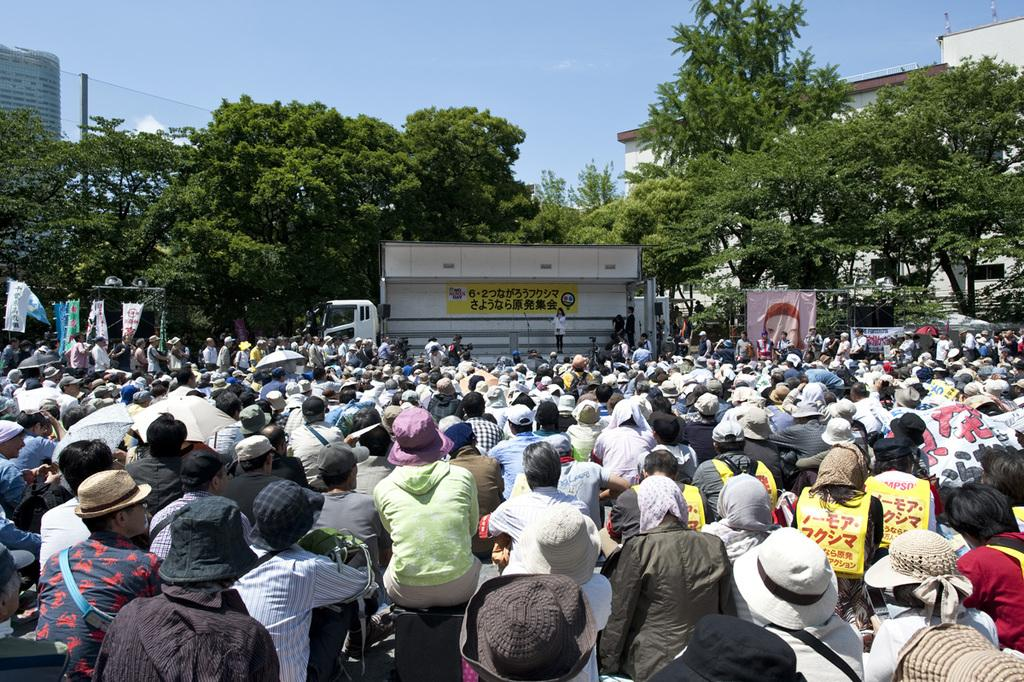What are the people in the image doing? People are sitting in the image, from left to right. What can be seen in the background of the image? There are trees in the background of the image. What is the background of the image? The background of the image is the sky. How many eyes can be seen on the chin of the person on the left? There are no eyes visible on the chin of the person on the left, as the image does not show any close-up or unusual details of the people's faces. 